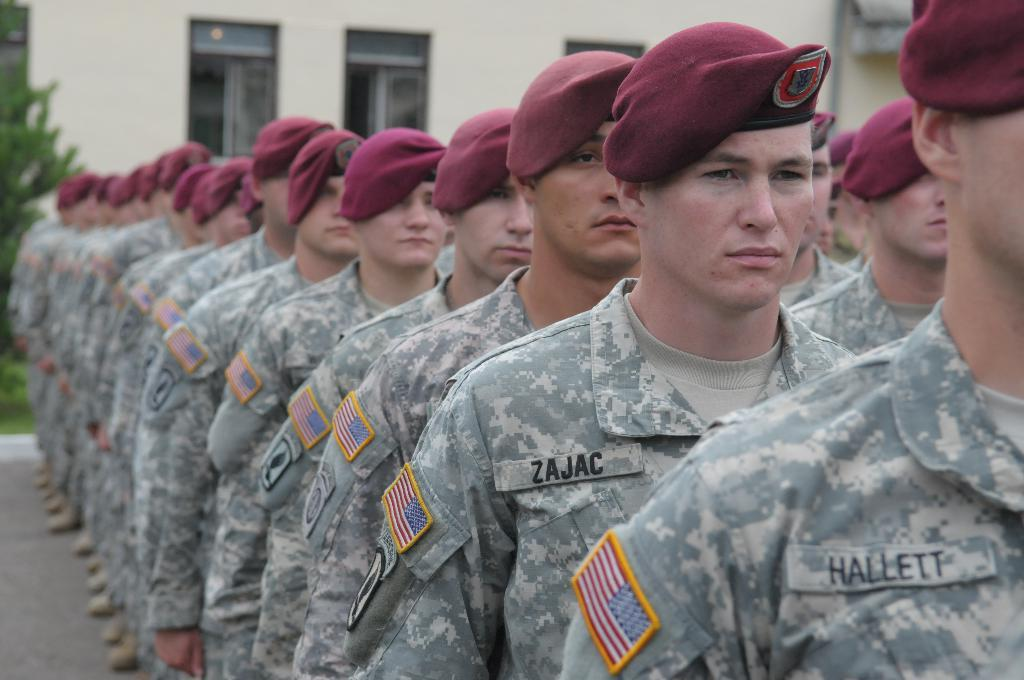What can be seen in the foreground of the image? There are men in the foreground of the image. What are the men wearing on their heads? The men are wearing caps. What type of clothing are the men wearing? The men are wearing military dress. Where are the men standing in the image? The men are standing on the road. What can be seen in the background of the image? There is greenery and a building in the background of the image. What month is it in the image? The month cannot be determined from the image, as there is no information about the time of year. How much sugar is present in the image? There is no sugar visible in the image. 